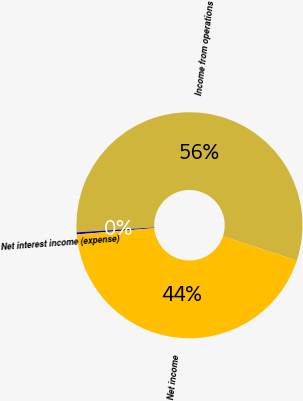<chart> <loc_0><loc_0><loc_500><loc_500><pie_chart><fcel>Income from operations<fcel>Net interest income (expense)<fcel>Net income<nl><fcel>56.06%<fcel>0.29%<fcel>43.65%<nl></chart> 